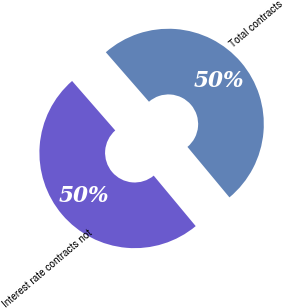Convert chart to OTSL. <chart><loc_0><loc_0><loc_500><loc_500><pie_chart><fcel>Interest rate contracts not<fcel>Total contracts<nl><fcel>49.63%<fcel>50.37%<nl></chart> 